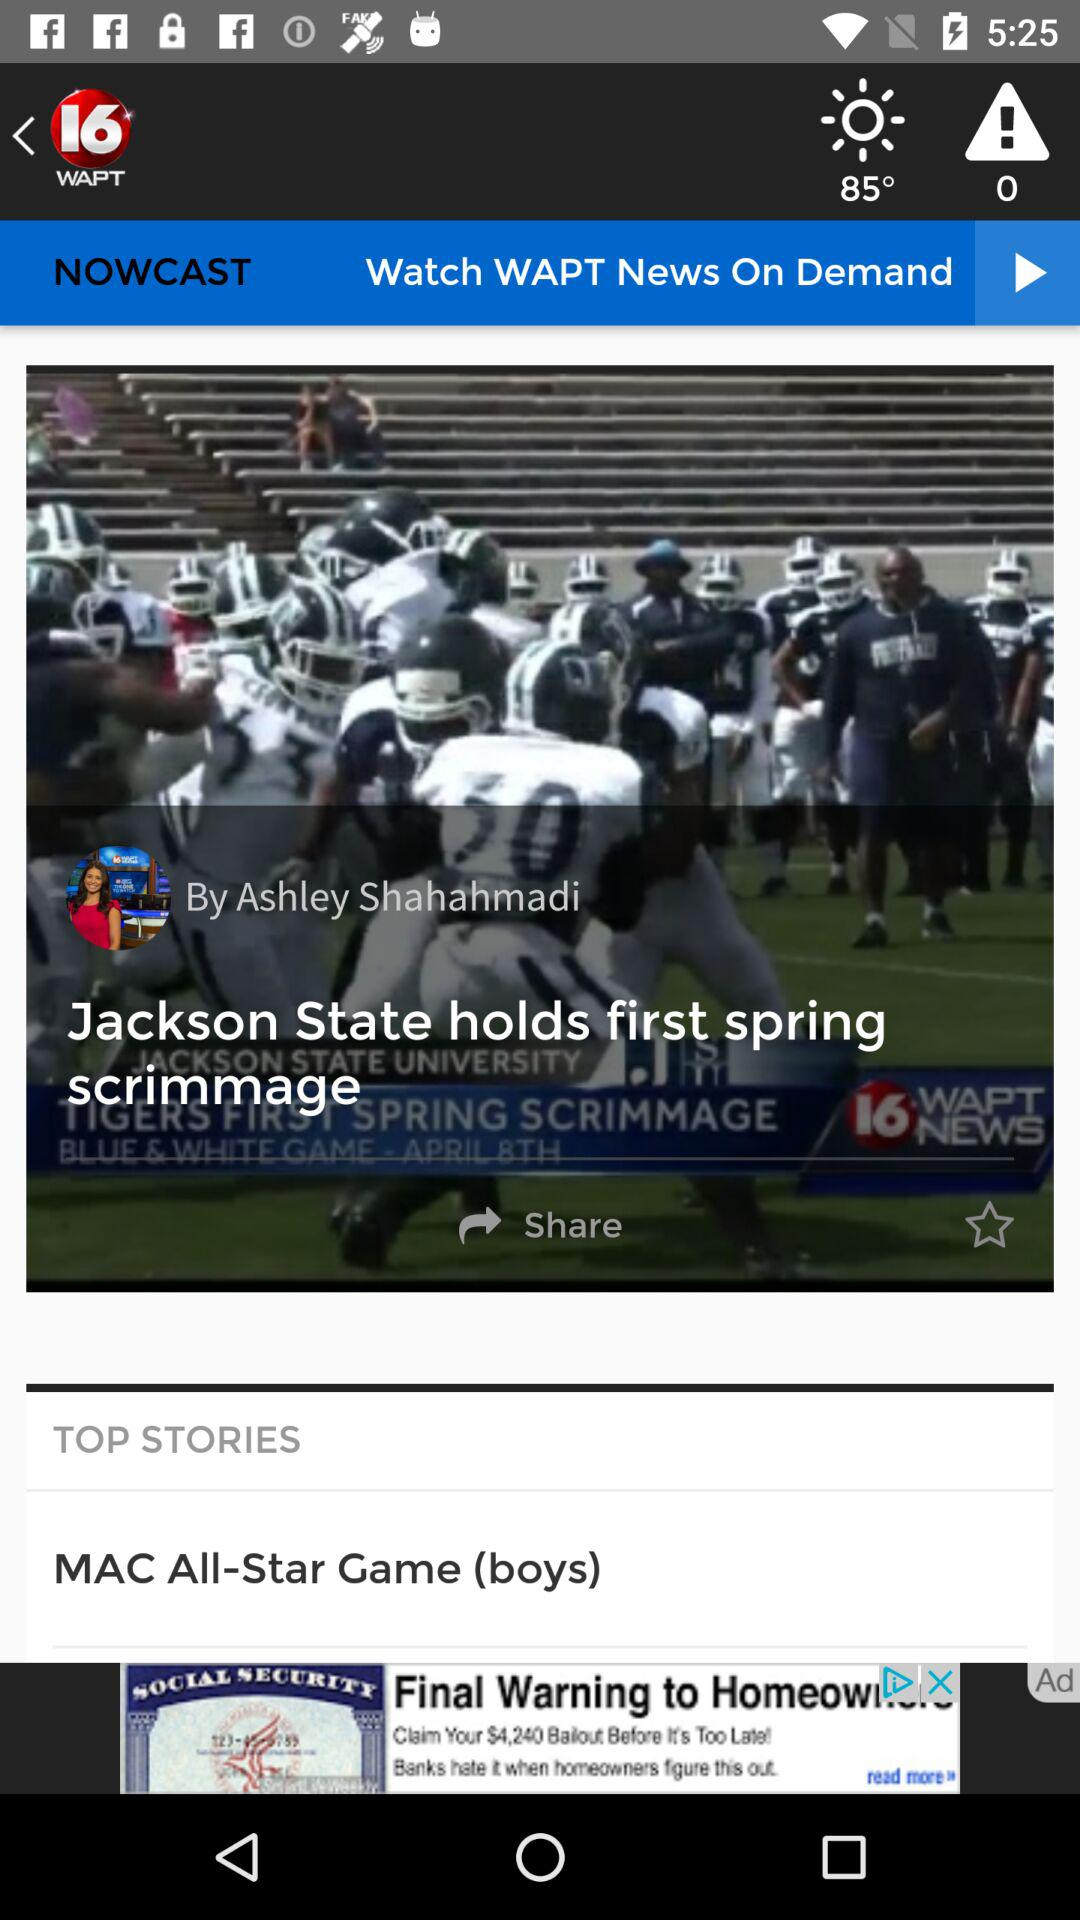What is the news channel name? The news channel name is "WAPT". 